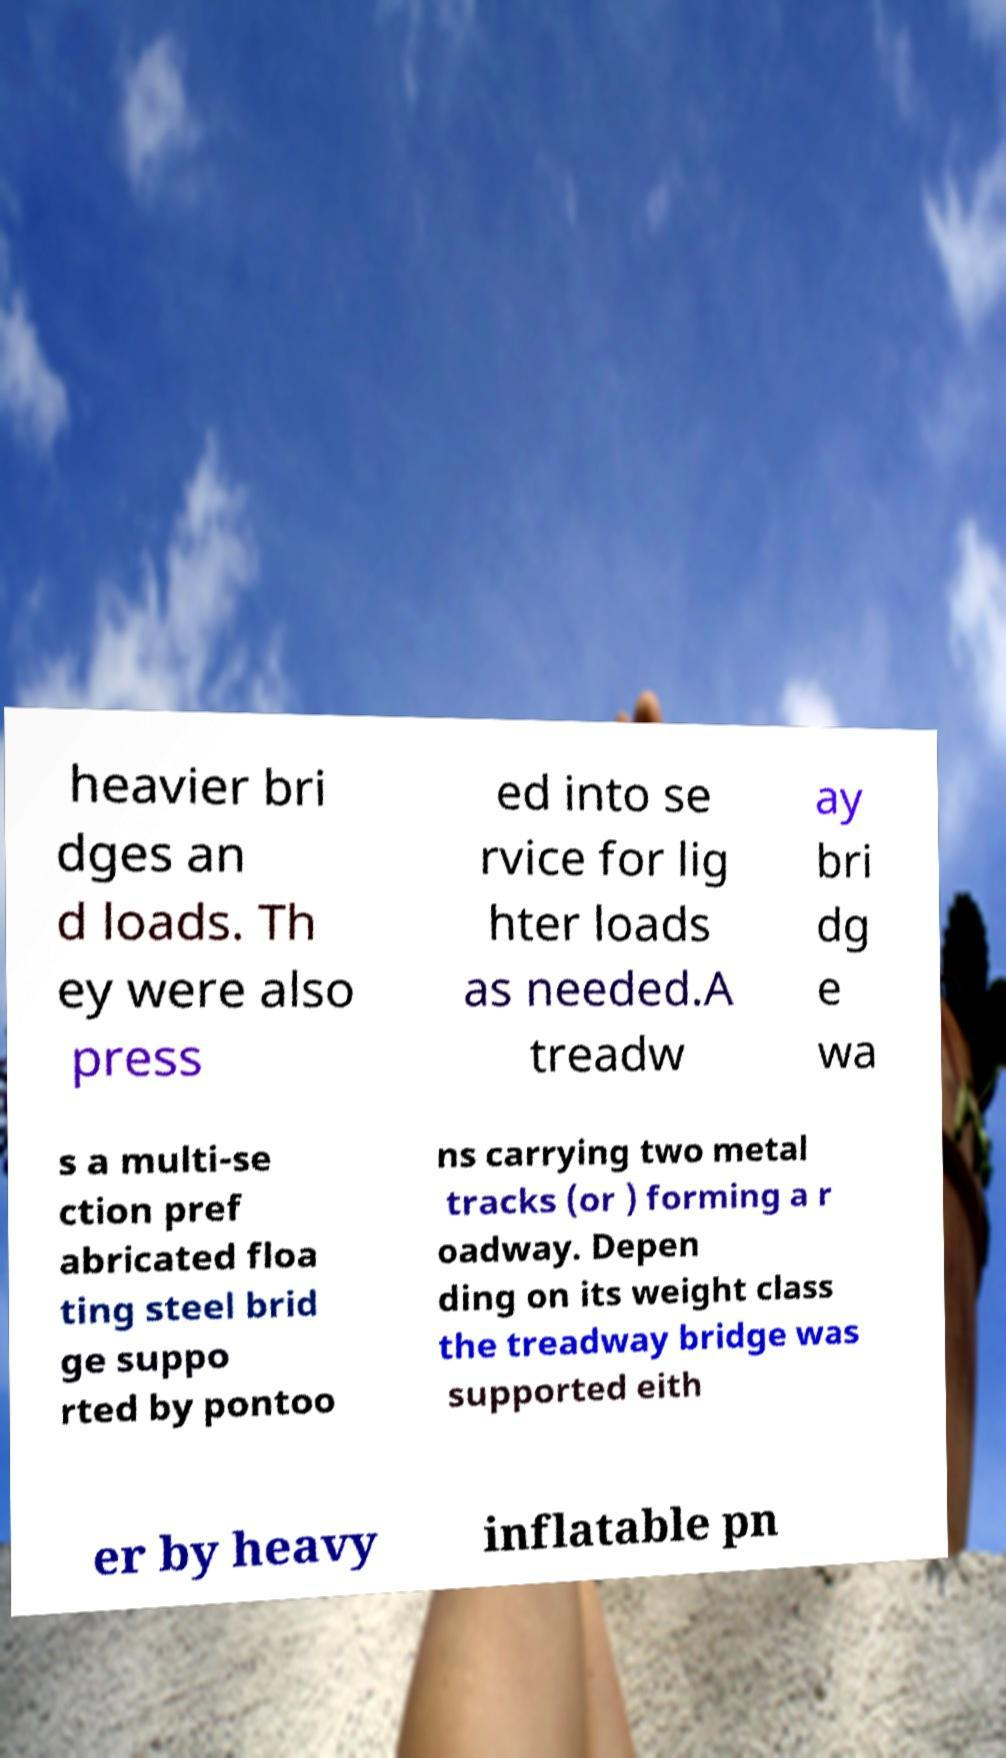Please identify and transcribe the text found in this image. heavier bri dges an d loads. Th ey were also press ed into se rvice for lig hter loads as needed.A treadw ay bri dg e wa s a multi-se ction pref abricated floa ting steel brid ge suppo rted by pontoo ns carrying two metal tracks (or ) forming a r oadway. Depen ding on its weight class the treadway bridge was supported eith er by heavy inflatable pn 